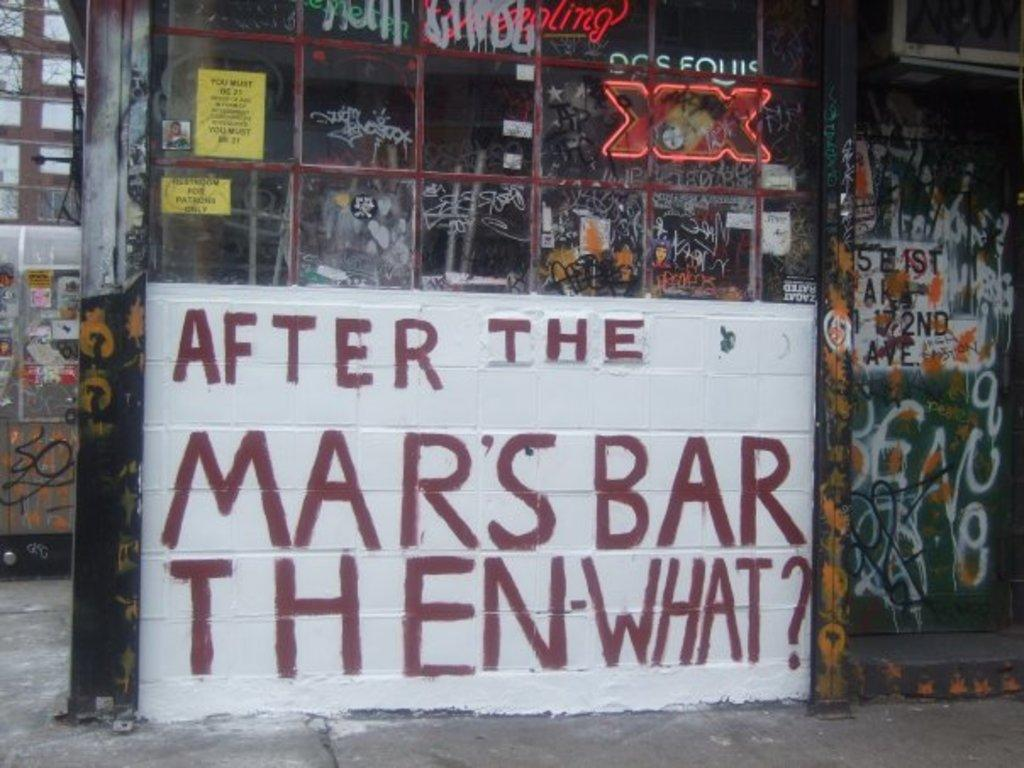What is present on the wall in the image? There is a wall in the image, and text is written on it. Posters are also pasted on the wall. Can you describe the text on the wall? The text on the wall is written in a way that is visible in the image. What else is displayed in the image besides the wall? Digital text is displayed in the image. What type of tooth is shown in the image? There is no tooth present in the image. How does the hammer contribute to the image? There is no hammer present in the image. 